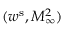Convert formula to latex. <formula><loc_0><loc_0><loc_500><loc_500>( w ^ { s } , M _ { \infty } ^ { 2 } )</formula> 